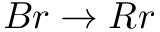Convert formula to latex. <formula><loc_0><loc_0><loc_500><loc_500>B r \rightarrow R r</formula> 